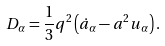Convert formula to latex. <formula><loc_0><loc_0><loc_500><loc_500>D _ { \alpha } = \frac { 1 } { 3 } q ^ { 2 } \left ( \dot { a } _ { \alpha } - a ^ { 2 } u _ { \alpha } \right ) .</formula> 